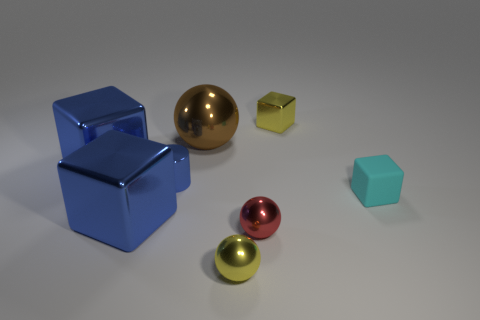Is there any other thing that is the same material as the cyan object?
Make the answer very short. No. Is there anything else of the same color as the big metal sphere?
Offer a very short reply. No. There is a sphere behind the shiny ball on the right side of the tiny yellow shiny object that is in front of the tiny yellow cube; what size is it?
Provide a short and direct response. Large. Are there any large objects in front of the large brown ball?
Your response must be concise. Yes. What is the size of the brown ball that is the same material as the tiny yellow ball?
Provide a short and direct response. Large. How many tiny red things are the same shape as the big brown metallic thing?
Give a very brief answer. 1. Does the brown sphere have the same material as the block that is behind the brown shiny thing?
Ensure brevity in your answer.  Yes. Are there more objects that are left of the rubber thing than metallic things?
Give a very brief answer. No. There is a shiny object that is the same color as the tiny shiny block; what is its shape?
Provide a short and direct response. Sphere. Is there a cylinder made of the same material as the yellow ball?
Provide a short and direct response. Yes. 